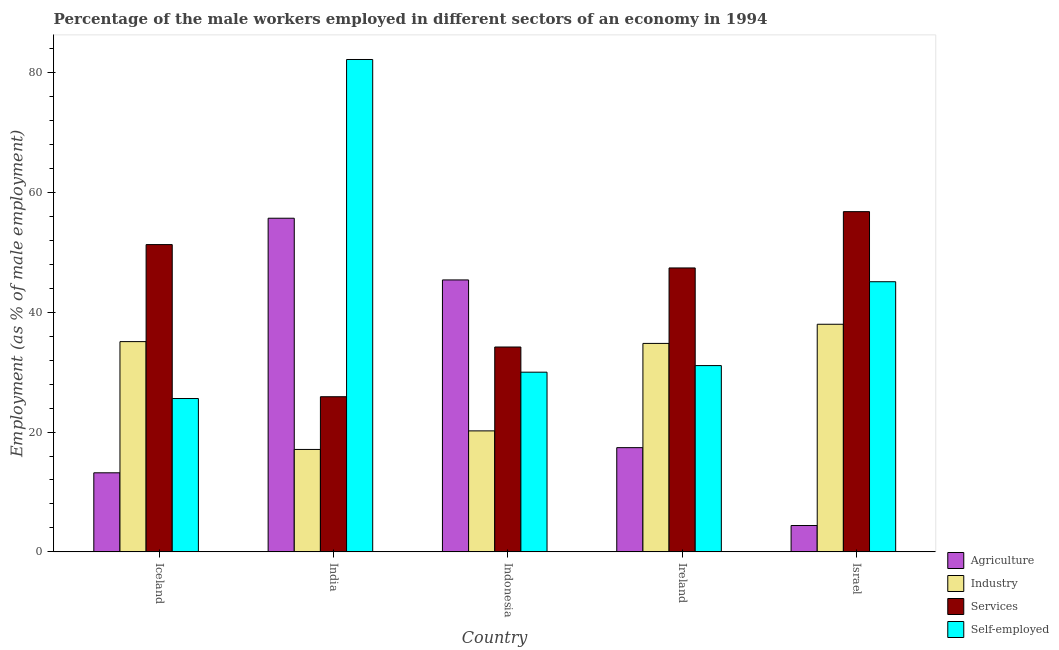Are the number of bars per tick equal to the number of legend labels?
Your answer should be very brief. Yes. Are the number of bars on each tick of the X-axis equal?
Provide a short and direct response. Yes. In how many cases, is the number of bars for a given country not equal to the number of legend labels?
Keep it short and to the point. 0. What is the percentage of self employed male workers in Iceland?
Ensure brevity in your answer.  25.6. Across all countries, what is the maximum percentage of male workers in services?
Offer a very short reply. 56.8. Across all countries, what is the minimum percentage of male workers in services?
Provide a short and direct response. 25.9. In which country was the percentage of self employed male workers minimum?
Your answer should be compact. Iceland. What is the total percentage of self employed male workers in the graph?
Provide a succinct answer. 214. What is the difference between the percentage of male workers in industry in Iceland and that in Ireland?
Provide a succinct answer. 0.3. What is the difference between the percentage of self employed male workers in Israel and the percentage of male workers in services in India?
Keep it short and to the point. 19.2. What is the average percentage of male workers in services per country?
Your answer should be very brief. 43.12. What is the difference between the percentage of male workers in industry and percentage of male workers in agriculture in India?
Provide a short and direct response. -38.6. In how many countries, is the percentage of male workers in services greater than 20 %?
Provide a short and direct response. 5. What is the ratio of the percentage of male workers in industry in Iceland to that in Indonesia?
Your answer should be very brief. 1.74. Is the percentage of male workers in agriculture in Ireland less than that in Israel?
Ensure brevity in your answer.  No. Is the difference between the percentage of male workers in agriculture in Ireland and Israel greater than the difference between the percentage of male workers in services in Ireland and Israel?
Ensure brevity in your answer.  Yes. What is the difference between the highest and the second highest percentage of male workers in agriculture?
Keep it short and to the point. 10.3. What is the difference between the highest and the lowest percentage of male workers in agriculture?
Provide a succinct answer. 51.3. In how many countries, is the percentage of male workers in industry greater than the average percentage of male workers in industry taken over all countries?
Provide a succinct answer. 3. Is the sum of the percentage of male workers in industry in Iceland and India greater than the maximum percentage of male workers in services across all countries?
Give a very brief answer. No. Is it the case that in every country, the sum of the percentage of male workers in industry and percentage of male workers in services is greater than the sum of percentage of self employed male workers and percentage of male workers in agriculture?
Keep it short and to the point. No. What does the 3rd bar from the left in Ireland represents?
Your answer should be compact. Services. What does the 4th bar from the right in Ireland represents?
Keep it short and to the point. Agriculture. How many bars are there?
Offer a terse response. 20. Does the graph contain any zero values?
Keep it short and to the point. No. Where does the legend appear in the graph?
Ensure brevity in your answer.  Bottom right. What is the title of the graph?
Your answer should be very brief. Percentage of the male workers employed in different sectors of an economy in 1994. What is the label or title of the X-axis?
Your response must be concise. Country. What is the label or title of the Y-axis?
Your answer should be compact. Employment (as % of male employment). What is the Employment (as % of male employment) in Agriculture in Iceland?
Provide a short and direct response. 13.2. What is the Employment (as % of male employment) in Industry in Iceland?
Provide a succinct answer. 35.1. What is the Employment (as % of male employment) of Services in Iceland?
Provide a succinct answer. 51.3. What is the Employment (as % of male employment) of Self-employed in Iceland?
Make the answer very short. 25.6. What is the Employment (as % of male employment) in Agriculture in India?
Give a very brief answer. 55.7. What is the Employment (as % of male employment) of Industry in India?
Your response must be concise. 17.1. What is the Employment (as % of male employment) in Services in India?
Provide a short and direct response. 25.9. What is the Employment (as % of male employment) of Self-employed in India?
Make the answer very short. 82.2. What is the Employment (as % of male employment) in Agriculture in Indonesia?
Give a very brief answer. 45.4. What is the Employment (as % of male employment) of Industry in Indonesia?
Your answer should be very brief. 20.2. What is the Employment (as % of male employment) in Services in Indonesia?
Ensure brevity in your answer.  34.2. What is the Employment (as % of male employment) in Agriculture in Ireland?
Offer a terse response. 17.4. What is the Employment (as % of male employment) of Industry in Ireland?
Provide a short and direct response. 34.8. What is the Employment (as % of male employment) of Services in Ireland?
Your answer should be compact. 47.4. What is the Employment (as % of male employment) of Self-employed in Ireland?
Offer a very short reply. 31.1. What is the Employment (as % of male employment) of Agriculture in Israel?
Your answer should be compact. 4.4. What is the Employment (as % of male employment) of Services in Israel?
Make the answer very short. 56.8. What is the Employment (as % of male employment) of Self-employed in Israel?
Provide a short and direct response. 45.1. Across all countries, what is the maximum Employment (as % of male employment) of Agriculture?
Your answer should be compact. 55.7. Across all countries, what is the maximum Employment (as % of male employment) of Industry?
Offer a very short reply. 38. Across all countries, what is the maximum Employment (as % of male employment) of Services?
Keep it short and to the point. 56.8. Across all countries, what is the maximum Employment (as % of male employment) of Self-employed?
Your response must be concise. 82.2. Across all countries, what is the minimum Employment (as % of male employment) in Agriculture?
Offer a very short reply. 4.4. Across all countries, what is the minimum Employment (as % of male employment) of Industry?
Offer a terse response. 17.1. Across all countries, what is the minimum Employment (as % of male employment) of Services?
Ensure brevity in your answer.  25.9. Across all countries, what is the minimum Employment (as % of male employment) in Self-employed?
Provide a short and direct response. 25.6. What is the total Employment (as % of male employment) in Agriculture in the graph?
Keep it short and to the point. 136.1. What is the total Employment (as % of male employment) in Industry in the graph?
Provide a succinct answer. 145.2. What is the total Employment (as % of male employment) in Services in the graph?
Keep it short and to the point. 215.6. What is the total Employment (as % of male employment) of Self-employed in the graph?
Your response must be concise. 214. What is the difference between the Employment (as % of male employment) in Agriculture in Iceland and that in India?
Ensure brevity in your answer.  -42.5. What is the difference between the Employment (as % of male employment) of Services in Iceland and that in India?
Provide a succinct answer. 25.4. What is the difference between the Employment (as % of male employment) of Self-employed in Iceland and that in India?
Your answer should be very brief. -56.6. What is the difference between the Employment (as % of male employment) in Agriculture in Iceland and that in Indonesia?
Provide a short and direct response. -32.2. What is the difference between the Employment (as % of male employment) of Self-employed in Iceland and that in Indonesia?
Your answer should be very brief. -4.4. What is the difference between the Employment (as % of male employment) in Industry in Iceland and that in Ireland?
Offer a terse response. 0.3. What is the difference between the Employment (as % of male employment) in Services in Iceland and that in Ireland?
Offer a terse response. 3.9. What is the difference between the Employment (as % of male employment) in Self-employed in Iceland and that in Israel?
Give a very brief answer. -19.5. What is the difference between the Employment (as % of male employment) in Industry in India and that in Indonesia?
Ensure brevity in your answer.  -3.1. What is the difference between the Employment (as % of male employment) in Self-employed in India and that in Indonesia?
Provide a short and direct response. 52.2. What is the difference between the Employment (as % of male employment) of Agriculture in India and that in Ireland?
Your answer should be compact. 38.3. What is the difference between the Employment (as % of male employment) in Industry in India and that in Ireland?
Offer a very short reply. -17.7. What is the difference between the Employment (as % of male employment) in Services in India and that in Ireland?
Your answer should be very brief. -21.5. What is the difference between the Employment (as % of male employment) in Self-employed in India and that in Ireland?
Your response must be concise. 51.1. What is the difference between the Employment (as % of male employment) of Agriculture in India and that in Israel?
Give a very brief answer. 51.3. What is the difference between the Employment (as % of male employment) of Industry in India and that in Israel?
Your response must be concise. -20.9. What is the difference between the Employment (as % of male employment) of Services in India and that in Israel?
Give a very brief answer. -30.9. What is the difference between the Employment (as % of male employment) of Self-employed in India and that in Israel?
Offer a terse response. 37.1. What is the difference between the Employment (as % of male employment) of Agriculture in Indonesia and that in Ireland?
Offer a terse response. 28. What is the difference between the Employment (as % of male employment) of Industry in Indonesia and that in Ireland?
Ensure brevity in your answer.  -14.6. What is the difference between the Employment (as % of male employment) of Services in Indonesia and that in Ireland?
Give a very brief answer. -13.2. What is the difference between the Employment (as % of male employment) in Self-employed in Indonesia and that in Ireland?
Your response must be concise. -1.1. What is the difference between the Employment (as % of male employment) of Industry in Indonesia and that in Israel?
Offer a terse response. -17.8. What is the difference between the Employment (as % of male employment) of Services in Indonesia and that in Israel?
Give a very brief answer. -22.6. What is the difference between the Employment (as % of male employment) of Self-employed in Indonesia and that in Israel?
Your response must be concise. -15.1. What is the difference between the Employment (as % of male employment) of Agriculture in Ireland and that in Israel?
Make the answer very short. 13. What is the difference between the Employment (as % of male employment) of Industry in Ireland and that in Israel?
Provide a succinct answer. -3.2. What is the difference between the Employment (as % of male employment) in Services in Ireland and that in Israel?
Keep it short and to the point. -9.4. What is the difference between the Employment (as % of male employment) of Self-employed in Ireland and that in Israel?
Give a very brief answer. -14. What is the difference between the Employment (as % of male employment) of Agriculture in Iceland and the Employment (as % of male employment) of Services in India?
Your response must be concise. -12.7. What is the difference between the Employment (as % of male employment) in Agriculture in Iceland and the Employment (as % of male employment) in Self-employed in India?
Give a very brief answer. -69. What is the difference between the Employment (as % of male employment) of Industry in Iceland and the Employment (as % of male employment) of Self-employed in India?
Your answer should be very brief. -47.1. What is the difference between the Employment (as % of male employment) of Services in Iceland and the Employment (as % of male employment) of Self-employed in India?
Make the answer very short. -30.9. What is the difference between the Employment (as % of male employment) in Agriculture in Iceland and the Employment (as % of male employment) in Industry in Indonesia?
Your answer should be compact. -7. What is the difference between the Employment (as % of male employment) of Agriculture in Iceland and the Employment (as % of male employment) of Services in Indonesia?
Provide a succinct answer. -21. What is the difference between the Employment (as % of male employment) of Agriculture in Iceland and the Employment (as % of male employment) of Self-employed in Indonesia?
Your answer should be very brief. -16.8. What is the difference between the Employment (as % of male employment) of Services in Iceland and the Employment (as % of male employment) of Self-employed in Indonesia?
Your response must be concise. 21.3. What is the difference between the Employment (as % of male employment) of Agriculture in Iceland and the Employment (as % of male employment) of Industry in Ireland?
Keep it short and to the point. -21.6. What is the difference between the Employment (as % of male employment) of Agriculture in Iceland and the Employment (as % of male employment) of Services in Ireland?
Offer a terse response. -34.2. What is the difference between the Employment (as % of male employment) in Agriculture in Iceland and the Employment (as % of male employment) in Self-employed in Ireland?
Make the answer very short. -17.9. What is the difference between the Employment (as % of male employment) in Services in Iceland and the Employment (as % of male employment) in Self-employed in Ireland?
Make the answer very short. 20.2. What is the difference between the Employment (as % of male employment) of Agriculture in Iceland and the Employment (as % of male employment) of Industry in Israel?
Your response must be concise. -24.8. What is the difference between the Employment (as % of male employment) in Agriculture in Iceland and the Employment (as % of male employment) in Services in Israel?
Offer a very short reply. -43.6. What is the difference between the Employment (as % of male employment) in Agriculture in Iceland and the Employment (as % of male employment) in Self-employed in Israel?
Keep it short and to the point. -31.9. What is the difference between the Employment (as % of male employment) in Industry in Iceland and the Employment (as % of male employment) in Services in Israel?
Keep it short and to the point. -21.7. What is the difference between the Employment (as % of male employment) in Agriculture in India and the Employment (as % of male employment) in Industry in Indonesia?
Your response must be concise. 35.5. What is the difference between the Employment (as % of male employment) of Agriculture in India and the Employment (as % of male employment) of Services in Indonesia?
Your answer should be very brief. 21.5. What is the difference between the Employment (as % of male employment) in Agriculture in India and the Employment (as % of male employment) in Self-employed in Indonesia?
Offer a very short reply. 25.7. What is the difference between the Employment (as % of male employment) in Industry in India and the Employment (as % of male employment) in Services in Indonesia?
Make the answer very short. -17.1. What is the difference between the Employment (as % of male employment) of Industry in India and the Employment (as % of male employment) of Self-employed in Indonesia?
Give a very brief answer. -12.9. What is the difference between the Employment (as % of male employment) of Services in India and the Employment (as % of male employment) of Self-employed in Indonesia?
Provide a succinct answer. -4.1. What is the difference between the Employment (as % of male employment) of Agriculture in India and the Employment (as % of male employment) of Industry in Ireland?
Provide a short and direct response. 20.9. What is the difference between the Employment (as % of male employment) of Agriculture in India and the Employment (as % of male employment) of Services in Ireland?
Offer a very short reply. 8.3. What is the difference between the Employment (as % of male employment) of Agriculture in India and the Employment (as % of male employment) of Self-employed in Ireland?
Give a very brief answer. 24.6. What is the difference between the Employment (as % of male employment) of Industry in India and the Employment (as % of male employment) of Services in Ireland?
Your response must be concise. -30.3. What is the difference between the Employment (as % of male employment) in Industry in India and the Employment (as % of male employment) in Services in Israel?
Offer a terse response. -39.7. What is the difference between the Employment (as % of male employment) in Services in India and the Employment (as % of male employment) in Self-employed in Israel?
Make the answer very short. -19.2. What is the difference between the Employment (as % of male employment) in Agriculture in Indonesia and the Employment (as % of male employment) in Services in Ireland?
Give a very brief answer. -2. What is the difference between the Employment (as % of male employment) in Industry in Indonesia and the Employment (as % of male employment) in Services in Ireland?
Provide a succinct answer. -27.2. What is the difference between the Employment (as % of male employment) in Services in Indonesia and the Employment (as % of male employment) in Self-employed in Ireland?
Give a very brief answer. 3.1. What is the difference between the Employment (as % of male employment) in Industry in Indonesia and the Employment (as % of male employment) in Services in Israel?
Make the answer very short. -36.6. What is the difference between the Employment (as % of male employment) of Industry in Indonesia and the Employment (as % of male employment) of Self-employed in Israel?
Give a very brief answer. -24.9. What is the difference between the Employment (as % of male employment) in Agriculture in Ireland and the Employment (as % of male employment) in Industry in Israel?
Keep it short and to the point. -20.6. What is the difference between the Employment (as % of male employment) in Agriculture in Ireland and the Employment (as % of male employment) in Services in Israel?
Your answer should be compact. -39.4. What is the difference between the Employment (as % of male employment) of Agriculture in Ireland and the Employment (as % of male employment) of Self-employed in Israel?
Your answer should be very brief. -27.7. What is the average Employment (as % of male employment) of Agriculture per country?
Your answer should be very brief. 27.22. What is the average Employment (as % of male employment) in Industry per country?
Ensure brevity in your answer.  29.04. What is the average Employment (as % of male employment) in Services per country?
Keep it short and to the point. 43.12. What is the average Employment (as % of male employment) of Self-employed per country?
Provide a short and direct response. 42.8. What is the difference between the Employment (as % of male employment) in Agriculture and Employment (as % of male employment) in Industry in Iceland?
Keep it short and to the point. -21.9. What is the difference between the Employment (as % of male employment) in Agriculture and Employment (as % of male employment) in Services in Iceland?
Give a very brief answer. -38.1. What is the difference between the Employment (as % of male employment) in Agriculture and Employment (as % of male employment) in Self-employed in Iceland?
Make the answer very short. -12.4. What is the difference between the Employment (as % of male employment) of Industry and Employment (as % of male employment) of Services in Iceland?
Your answer should be compact. -16.2. What is the difference between the Employment (as % of male employment) in Industry and Employment (as % of male employment) in Self-employed in Iceland?
Give a very brief answer. 9.5. What is the difference between the Employment (as % of male employment) in Services and Employment (as % of male employment) in Self-employed in Iceland?
Your answer should be very brief. 25.7. What is the difference between the Employment (as % of male employment) of Agriculture and Employment (as % of male employment) of Industry in India?
Offer a terse response. 38.6. What is the difference between the Employment (as % of male employment) of Agriculture and Employment (as % of male employment) of Services in India?
Your answer should be compact. 29.8. What is the difference between the Employment (as % of male employment) in Agriculture and Employment (as % of male employment) in Self-employed in India?
Your response must be concise. -26.5. What is the difference between the Employment (as % of male employment) in Industry and Employment (as % of male employment) in Self-employed in India?
Provide a short and direct response. -65.1. What is the difference between the Employment (as % of male employment) of Services and Employment (as % of male employment) of Self-employed in India?
Your response must be concise. -56.3. What is the difference between the Employment (as % of male employment) in Agriculture and Employment (as % of male employment) in Industry in Indonesia?
Offer a very short reply. 25.2. What is the difference between the Employment (as % of male employment) of Agriculture and Employment (as % of male employment) of Services in Indonesia?
Offer a terse response. 11.2. What is the difference between the Employment (as % of male employment) of Agriculture and Employment (as % of male employment) of Industry in Ireland?
Your answer should be compact. -17.4. What is the difference between the Employment (as % of male employment) of Agriculture and Employment (as % of male employment) of Self-employed in Ireland?
Provide a succinct answer. -13.7. What is the difference between the Employment (as % of male employment) in Industry and Employment (as % of male employment) in Self-employed in Ireland?
Your answer should be very brief. 3.7. What is the difference between the Employment (as % of male employment) in Agriculture and Employment (as % of male employment) in Industry in Israel?
Give a very brief answer. -33.6. What is the difference between the Employment (as % of male employment) of Agriculture and Employment (as % of male employment) of Services in Israel?
Keep it short and to the point. -52.4. What is the difference between the Employment (as % of male employment) of Agriculture and Employment (as % of male employment) of Self-employed in Israel?
Your answer should be compact. -40.7. What is the difference between the Employment (as % of male employment) of Industry and Employment (as % of male employment) of Services in Israel?
Your answer should be very brief. -18.8. What is the ratio of the Employment (as % of male employment) of Agriculture in Iceland to that in India?
Make the answer very short. 0.24. What is the ratio of the Employment (as % of male employment) in Industry in Iceland to that in India?
Make the answer very short. 2.05. What is the ratio of the Employment (as % of male employment) of Services in Iceland to that in India?
Your answer should be compact. 1.98. What is the ratio of the Employment (as % of male employment) of Self-employed in Iceland to that in India?
Provide a short and direct response. 0.31. What is the ratio of the Employment (as % of male employment) in Agriculture in Iceland to that in Indonesia?
Give a very brief answer. 0.29. What is the ratio of the Employment (as % of male employment) in Industry in Iceland to that in Indonesia?
Your response must be concise. 1.74. What is the ratio of the Employment (as % of male employment) in Self-employed in Iceland to that in Indonesia?
Keep it short and to the point. 0.85. What is the ratio of the Employment (as % of male employment) of Agriculture in Iceland to that in Ireland?
Your response must be concise. 0.76. What is the ratio of the Employment (as % of male employment) of Industry in Iceland to that in Ireland?
Offer a terse response. 1.01. What is the ratio of the Employment (as % of male employment) in Services in Iceland to that in Ireland?
Provide a succinct answer. 1.08. What is the ratio of the Employment (as % of male employment) of Self-employed in Iceland to that in Ireland?
Give a very brief answer. 0.82. What is the ratio of the Employment (as % of male employment) of Agriculture in Iceland to that in Israel?
Give a very brief answer. 3. What is the ratio of the Employment (as % of male employment) in Industry in Iceland to that in Israel?
Your answer should be compact. 0.92. What is the ratio of the Employment (as % of male employment) in Services in Iceland to that in Israel?
Give a very brief answer. 0.9. What is the ratio of the Employment (as % of male employment) in Self-employed in Iceland to that in Israel?
Your response must be concise. 0.57. What is the ratio of the Employment (as % of male employment) of Agriculture in India to that in Indonesia?
Make the answer very short. 1.23. What is the ratio of the Employment (as % of male employment) in Industry in India to that in Indonesia?
Make the answer very short. 0.85. What is the ratio of the Employment (as % of male employment) of Services in India to that in Indonesia?
Your response must be concise. 0.76. What is the ratio of the Employment (as % of male employment) in Self-employed in India to that in Indonesia?
Offer a very short reply. 2.74. What is the ratio of the Employment (as % of male employment) of Agriculture in India to that in Ireland?
Keep it short and to the point. 3.2. What is the ratio of the Employment (as % of male employment) in Industry in India to that in Ireland?
Provide a succinct answer. 0.49. What is the ratio of the Employment (as % of male employment) of Services in India to that in Ireland?
Ensure brevity in your answer.  0.55. What is the ratio of the Employment (as % of male employment) in Self-employed in India to that in Ireland?
Give a very brief answer. 2.64. What is the ratio of the Employment (as % of male employment) in Agriculture in India to that in Israel?
Your response must be concise. 12.66. What is the ratio of the Employment (as % of male employment) of Industry in India to that in Israel?
Your answer should be compact. 0.45. What is the ratio of the Employment (as % of male employment) of Services in India to that in Israel?
Your response must be concise. 0.46. What is the ratio of the Employment (as % of male employment) of Self-employed in India to that in Israel?
Provide a succinct answer. 1.82. What is the ratio of the Employment (as % of male employment) of Agriculture in Indonesia to that in Ireland?
Ensure brevity in your answer.  2.61. What is the ratio of the Employment (as % of male employment) of Industry in Indonesia to that in Ireland?
Your response must be concise. 0.58. What is the ratio of the Employment (as % of male employment) of Services in Indonesia to that in Ireland?
Your response must be concise. 0.72. What is the ratio of the Employment (as % of male employment) of Self-employed in Indonesia to that in Ireland?
Keep it short and to the point. 0.96. What is the ratio of the Employment (as % of male employment) in Agriculture in Indonesia to that in Israel?
Provide a short and direct response. 10.32. What is the ratio of the Employment (as % of male employment) of Industry in Indonesia to that in Israel?
Make the answer very short. 0.53. What is the ratio of the Employment (as % of male employment) of Services in Indonesia to that in Israel?
Your answer should be compact. 0.6. What is the ratio of the Employment (as % of male employment) in Self-employed in Indonesia to that in Israel?
Make the answer very short. 0.67. What is the ratio of the Employment (as % of male employment) of Agriculture in Ireland to that in Israel?
Your response must be concise. 3.95. What is the ratio of the Employment (as % of male employment) in Industry in Ireland to that in Israel?
Ensure brevity in your answer.  0.92. What is the ratio of the Employment (as % of male employment) of Services in Ireland to that in Israel?
Keep it short and to the point. 0.83. What is the ratio of the Employment (as % of male employment) of Self-employed in Ireland to that in Israel?
Give a very brief answer. 0.69. What is the difference between the highest and the second highest Employment (as % of male employment) in Services?
Provide a short and direct response. 5.5. What is the difference between the highest and the second highest Employment (as % of male employment) in Self-employed?
Give a very brief answer. 37.1. What is the difference between the highest and the lowest Employment (as % of male employment) in Agriculture?
Offer a terse response. 51.3. What is the difference between the highest and the lowest Employment (as % of male employment) of Industry?
Keep it short and to the point. 20.9. What is the difference between the highest and the lowest Employment (as % of male employment) in Services?
Offer a very short reply. 30.9. What is the difference between the highest and the lowest Employment (as % of male employment) of Self-employed?
Keep it short and to the point. 56.6. 